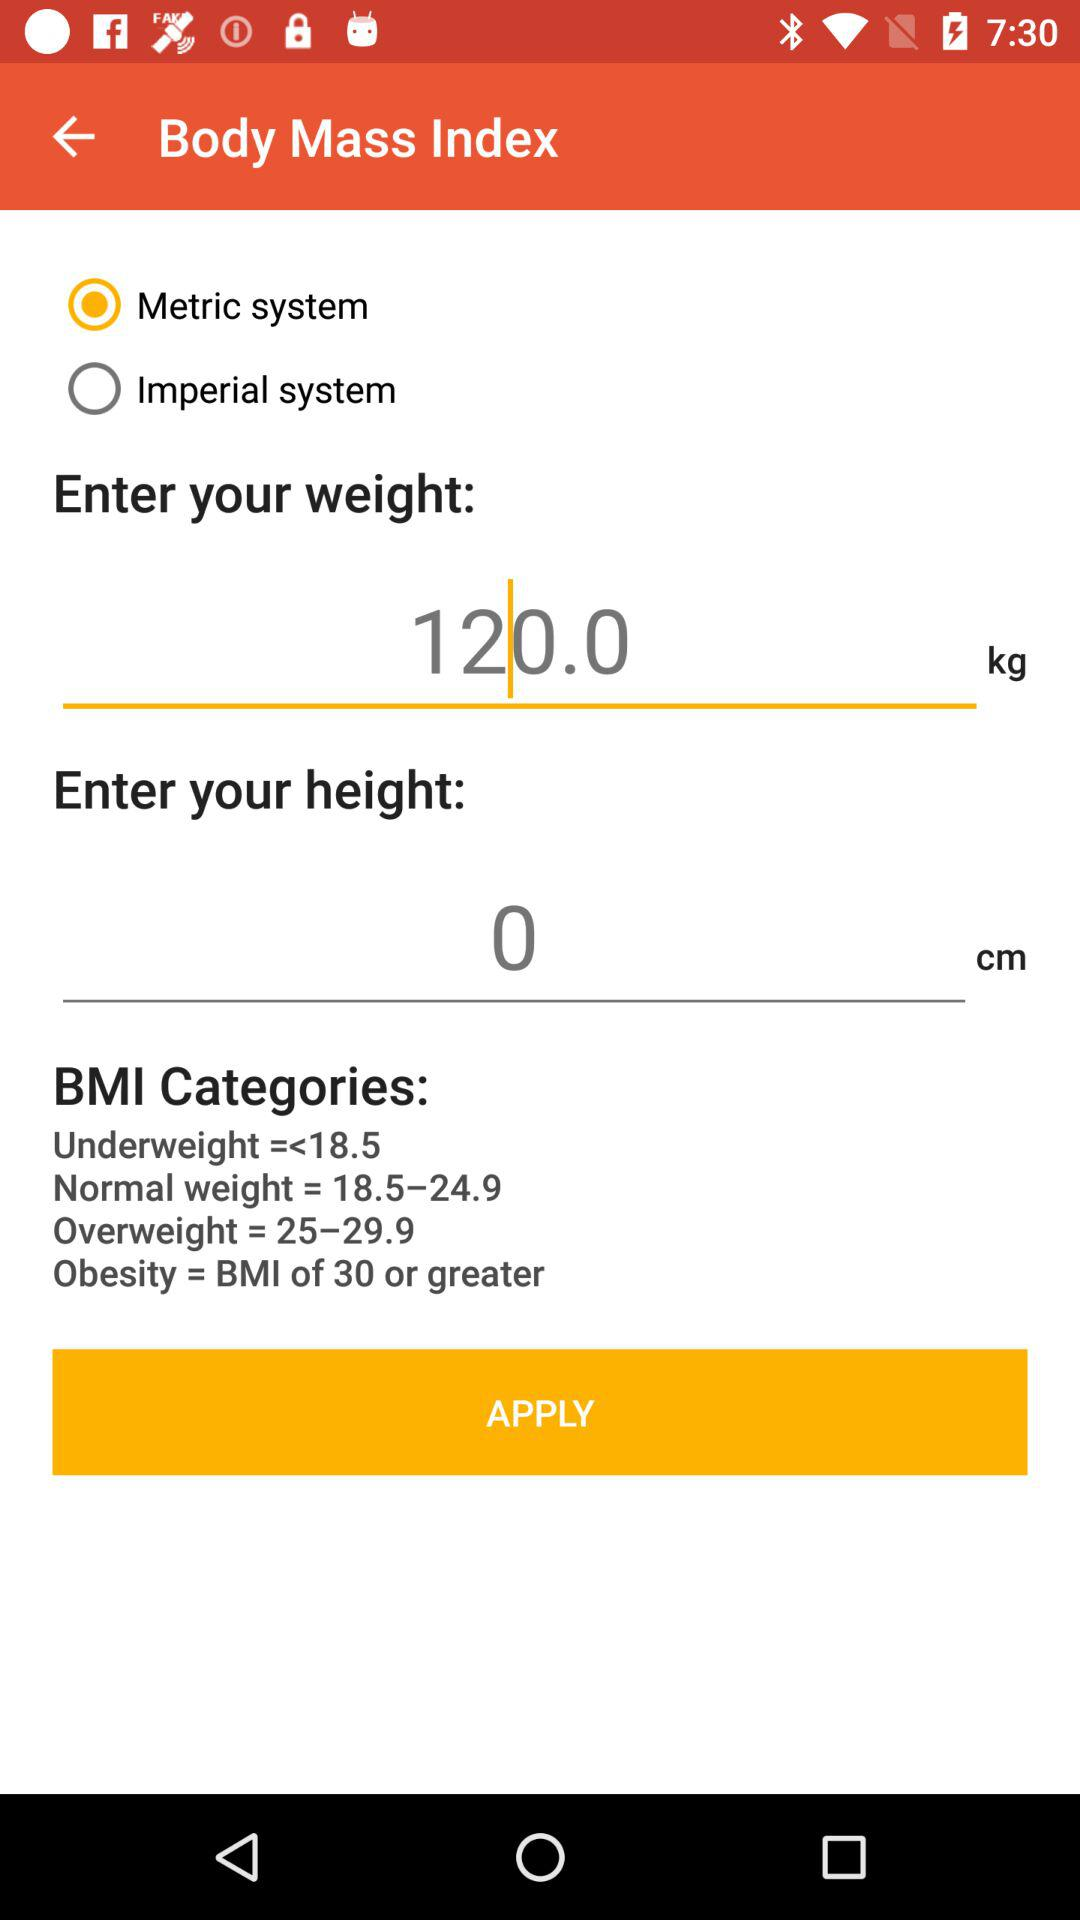What is the input value in the weight field? The input value in the weight field is 120. 